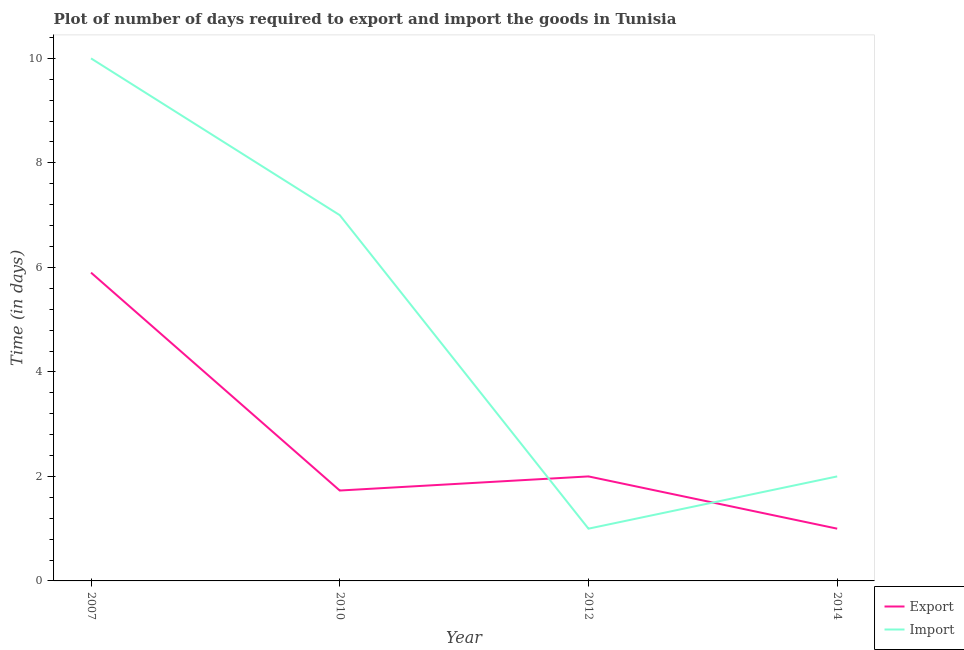How many different coloured lines are there?
Offer a very short reply. 2. Is the number of lines equal to the number of legend labels?
Ensure brevity in your answer.  Yes. What is the time required to import in 2007?
Offer a terse response. 10. Across all years, what is the maximum time required to import?
Your response must be concise. 10. Across all years, what is the minimum time required to import?
Provide a succinct answer. 1. In which year was the time required to import maximum?
Offer a terse response. 2007. What is the total time required to import in the graph?
Your answer should be compact. 20. What is the difference between the time required to import in 2007 and that in 2010?
Keep it short and to the point. 3. What is the average time required to import per year?
Your answer should be very brief. 5. In the year 2010, what is the difference between the time required to export and time required to import?
Your answer should be very brief. -5.27. What is the ratio of the time required to import in 2007 to that in 2014?
Provide a succinct answer. 5. Is the difference between the time required to import in 2012 and 2014 greater than the difference between the time required to export in 2012 and 2014?
Make the answer very short. No. Is the sum of the time required to import in 2010 and 2014 greater than the maximum time required to export across all years?
Give a very brief answer. Yes. Does the time required to import monotonically increase over the years?
Provide a short and direct response. No. Is the time required to import strictly greater than the time required to export over the years?
Offer a terse response. No. How many years are there in the graph?
Give a very brief answer. 4. Does the graph contain any zero values?
Your answer should be compact. No. Where does the legend appear in the graph?
Ensure brevity in your answer.  Bottom right. How many legend labels are there?
Your answer should be compact. 2. How are the legend labels stacked?
Provide a succinct answer. Vertical. What is the title of the graph?
Your answer should be compact. Plot of number of days required to export and import the goods in Tunisia. What is the label or title of the X-axis?
Your response must be concise. Year. What is the label or title of the Y-axis?
Provide a succinct answer. Time (in days). What is the Time (in days) of Export in 2007?
Give a very brief answer. 5.9. What is the Time (in days) in Import in 2007?
Give a very brief answer. 10. What is the Time (in days) in Export in 2010?
Make the answer very short. 1.73. What is the Time (in days) in Import in 2012?
Make the answer very short. 1. Across all years, what is the minimum Time (in days) of Export?
Keep it short and to the point. 1. What is the total Time (in days) of Export in the graph?
Offer a terse response. 10.63. What is the total Time (in days) in Import in the graph?
Provide a succinct answer. 20. What is the difference between the Time (in days) in Export in 2007 and that in 2010?
Provide a short and direct response. 4.17. What is the difference between the Time (in days) of Export in 2007 and that in 2012?
Make the answer very short. 3.9. What is the difference between the Time (in days) in Import in 2007 and that in 2012?
Provide a short and direct response. 9. What is the difference between the Time (in days) in Export in 2010 and that in 2012?
Provide a short and direct response. -0.27. What is the difference between the Time (in days) in Import in 2010 and that in 2012?
Provide a succinct answer. 6. What is the difference between the Time (in days) of Export in 2010 and that in 2014?
Offer a very short reply. 0.73. What is the difference between the Time (in days) in Import in 2012 and that in 2014?
Keep it short and to the point. -1. What is the difference between the Time (in days) in Export in 2007 and the Time (in days) in Import in 2010?
Ensure brevity in your answer.  -1.1. What is the difference between the Time (in days) in Export in 2007 and the Time (in days) in Import in 2012?
Ensure brevity in your answer.  4.9. What is the difference between the Time (in days) in Export in 2010 and the Time (in days) in Import in 2012?
Ensure brevity in your answer.  0.73. What is the difference between the Time (in days) in Export in 2010 and the Time (in days) in Import in 2014?
Offer a terse response. -0.27. What is the average Time (in days) of Export per year?
Keep it short and to the point. 2.66. In the year 2010, what is the difference between the Time (in days) of Export and Time (in days) of Import?
Offer a very short reply. -5.27. What is the ratio of the Time (in days) in Export in 2007 to that in 2010?
Give a very brief answer. 3.41. What is the ratio of the Time (in days) of Import in 2007 to that in 2010?
Keep it short and to the point. 1.43. What is the ratio of the Time (in days) of Export in 2007 to that in 2012?
Your response must be concise. 2.95. What is the ratio of the Time (in days) in Import in 2007 to that in 2014?
Offer a very short reply. 5. What is the ratio of the Time (in days) in Export in 2010 to that in 2012?
Give a very brief answer. 0.86. What is the ratio of the Time (in days) of Export in 2010 to that in 2014?
Offer a very short reply. 1.73. What is the ratio of the Time (in days) in Export in 2012 to that in 2014?
Make the answer very short. 2. What is the ratio of the Time (in days) in Import in 2012 to that in 2014?
Offer a terse response. 0.5. What is the difference between the highest and the second highest Time (in days) in Export?
Keep it short and to the point. 3.9. What is the difference between the highest and the second highest Time (in days) in Import?
Make the answer very short. 3. What is the difference between the highest and the lowest Time (in days) of Export?
Offer a terse response. 4.9. 